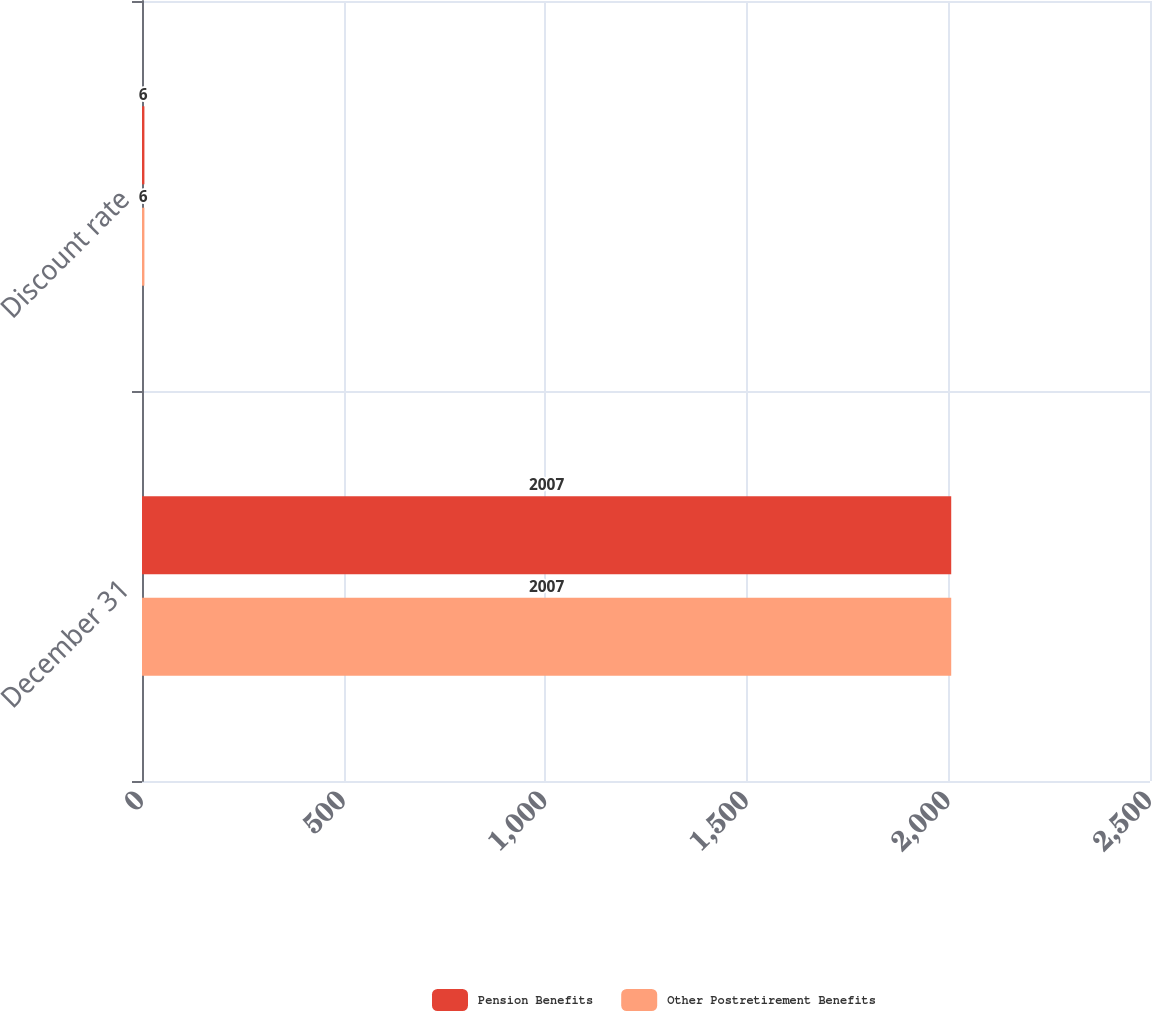Convert chart to OTSL. <chart><loc_0><loc_0><loc_500><loc_500><stacked_bar_chart><ecel><fcel>December 31<fcel>Discount rate<nl><fcel>Pension Benefits<fcel>2007<fcel>6<nl><fcel>Other Postretirement Benefits<fcel>2007<fcel>6<nl></chart> 